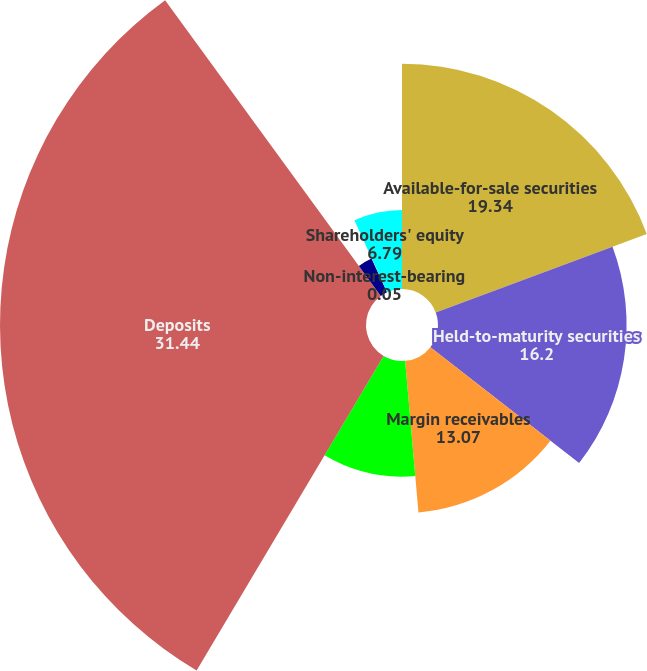<chart> <loc_0><loc_0><loc_500><loc_500><pie_chart><fcel>Available-for-sale securities<fcel>Held-to-maturity securities<fcel>Margin receivables<fcel>Loans receivable net<fcel>Deposits<fcel>Interest-bearing<fcel>Non-interest-bearing<fcel>Shareholders' equity<nl><fcel>19.34%<fcel>16.2%<fcel>13.07%<fcel>9.93%<fcel>31.44%<fcel>3.19%<fcel>0.05%<fcel>6.79%<nl></chart> 